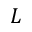Convert formula to latex. <formula><loc_0><loc_0><loc_500><loc_500>L</formula> 